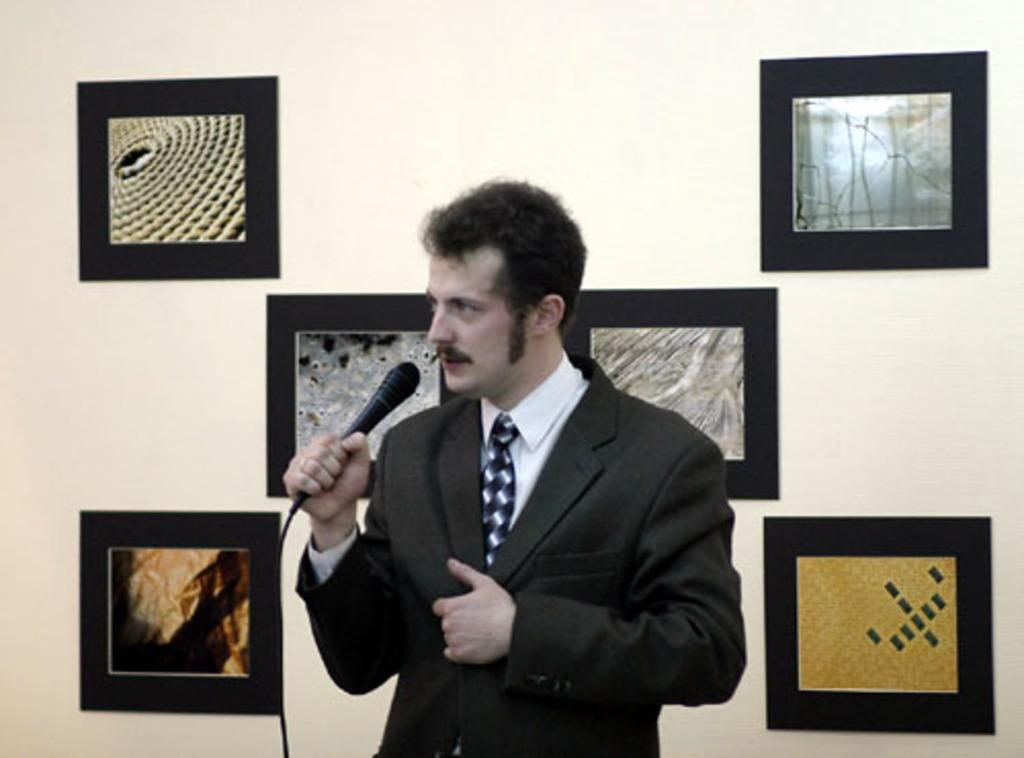Who is in the image? There is a man in the image. What is the man wearing? The man is wearing a black suit. What is the man holding in his hand? The man is holding a microphone in his hand. What can be seen in the background of the image? There is a wall in the background of the image, and frames are attached to the wall. What type of nose can be seen on the representative in the image? There is no representative present in the image, and therefore no nose can be observed. What is the man doing with the banana in the image? There is no banana present in the image; the man is holding a microphone. 